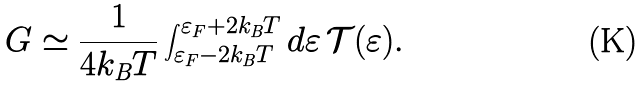Convert formula to latex. <formula><loc_0><loc_0><loc_500><loc_500>G \simeq \frac { 1 } { 4 k _ { \text {B} } T } \int _ { \varepsilon _ { F } - 2 k _ { \text {B} } T } ^ { \varepsilon _ { F } + 2 k _ { \text {B} } T } d \varepsilon \, \mathcal { T } ( \varepsilon ) .</formula> 